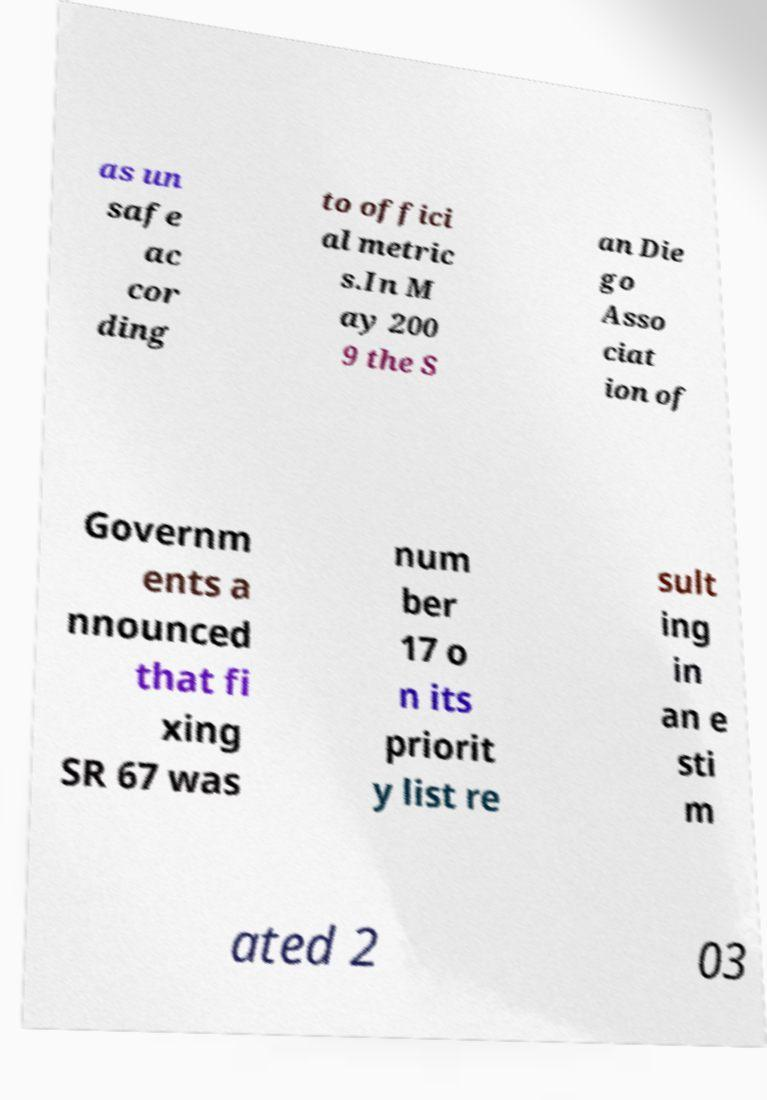Could you assist in decoding the text presented in this image and type it out clearly? as un safe ac cor ding to offici al metric s.In M ay 200 9 the S an Die go Asso ciat ion of Governm ents a nnounced that fi xing SR 67 was num ber 17 o n its priorit y list re sult ing in an e sti m ated 2 03 